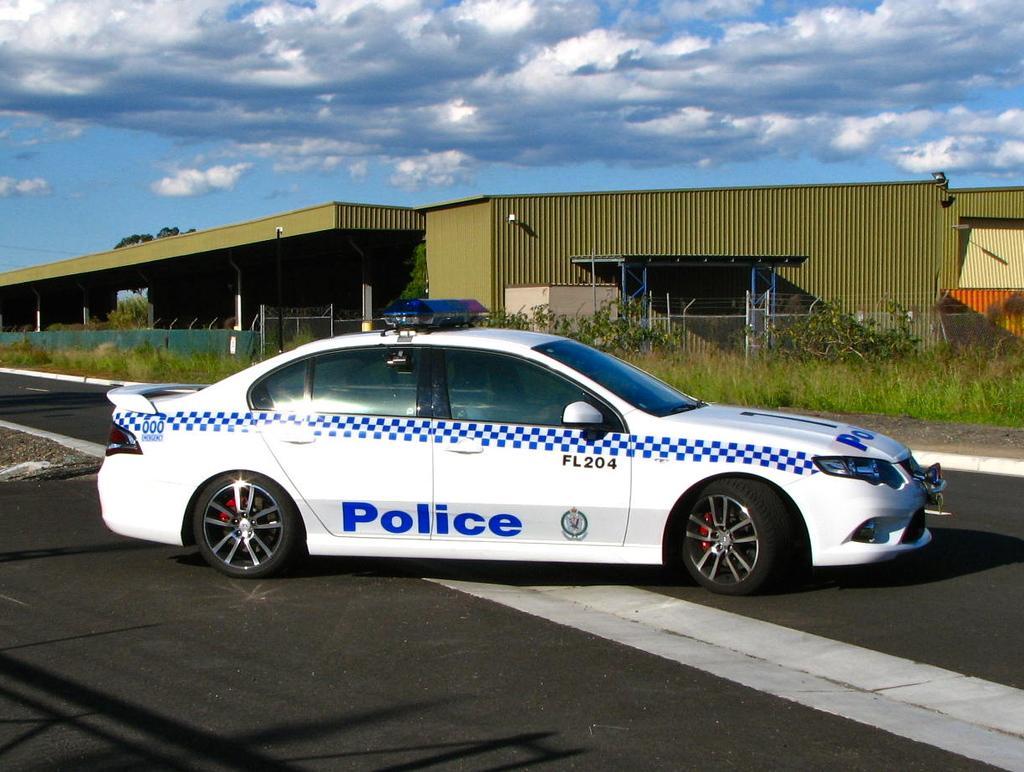Could you give a brief overview of what you see in this image? In this image we can see a police car placed on the road. In the background we can see group of plants ,building and the sky. 